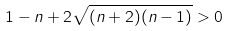<formula> <loc_0><loc_0><loc_500><loc_500>1 - n + 2 \sqrt { ( n + 2 ) ( n - 1 ) } > 0</formula> 